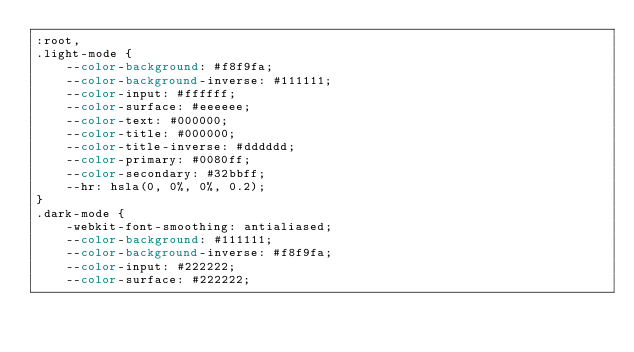<code> <loc_0><loc_0><loc_500><loc_500><_CSS_>:root,
.light-mode {
    --color-background: #f8f9fa;
    --color-background-inverse: #111111;
    --color-input: #ffffff;
    --color-surface: #eeeeee;
    --color-text: #000000;
    --color-title: #000000;
    --color-title-inverse: #dddddd;
    --color-primary: #0080ff;
    --color-secondary: #32bbff;
    --hr: hsla(0, 0%, 0%, 0.2);
}
.dark-mode {
    -webkit-font-smoothing: antialiased;
    --color-background: #111111;
    --color-background-inverse: #f8f9fa;
    --color-input: #222222;
    --color-surface: #222222;</code> 